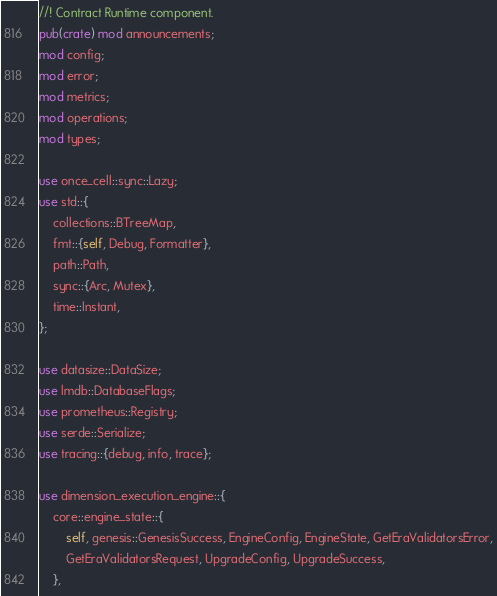Convert code to text. <code><loc_0><loc_0><loc_500><loc_500><_Rust_>//! Contract Runtime component.
pub(crate) mod announcements;
mod config;
mod error;
mod metrics;
mod operations;
mod types;

use once_cell::sync::Lazy;
use std::{
    collections::BTreeMap,
    fmt::{self, Debug, Formatter},
    path::Path,
    sync::{Arc, Mutex},
    time::Instant,
};

use datasize::DataSize;
use lmdb::DatabaseFlags;
use prometheus::Registry;
use serde::Serialize;
use tracing::{debug, info, trace};

use dimension_execution_engine::{
    core::engine_state::{
        self, genesis::GenesisSuccess, EngineConfig, EngineState, GetEraValidatorsError,
        GetEraValidatorsRequest, UpgradeConfig, UpgradeSuccess,
    },</code> 